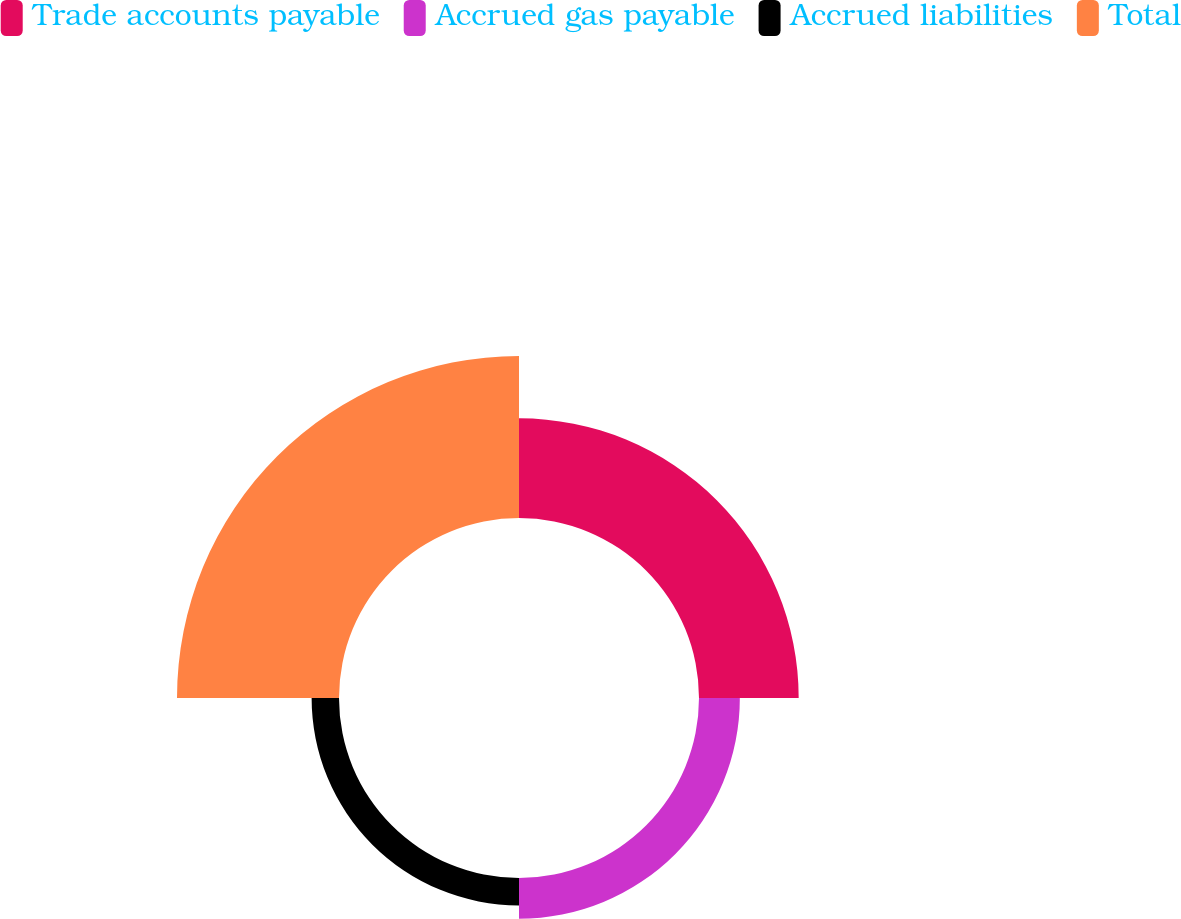Convert chart. <chart><loc_0><loc_0><loc_500><loc_500><pie_chart><fcel>Trade accounts payable<fcel>Accrued gas payable<fcel>Accrued liabilities<fcel>Total<nl><fcel>30.22%<fcel>12.38%<fcel>8.3%<fcel>49.11%<nl></chart> 